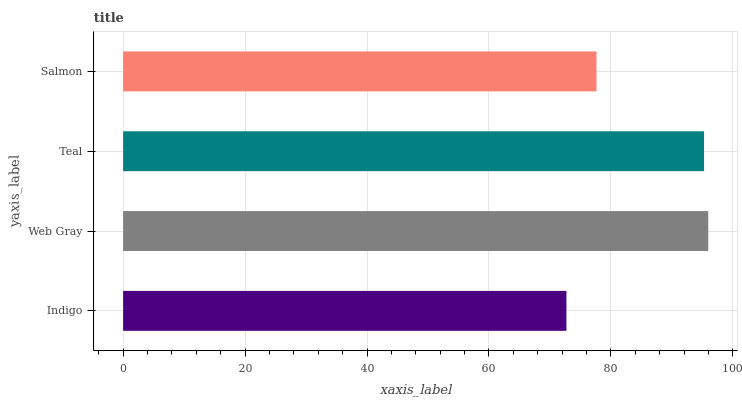Is Indigo the minimum?
Answer yes or no. Yes. Is Web Gray the maximum?
Answer yes or no. Yes. Is Teal the minimum?
Answer yes or no. No. Is Teal the maximum?
Answer yes or no. No. Is Web Gray greater than Teal?
Answer yes or no. Yes. Is Teal less than Web Gray?
Answer yes or no. Yes. Is Teal greater than Web Gray?
Answer yes or no. No. Is Web Gray less than Teal?
Answer yes or no. No. Is Teal the high median?
Answer yes or no. Yes. Is Salmon the low median?
Answer yes or no. Yes. Is Indigo the high median?
Answer yes or no. No. Is Teal the low median?
Answer yes or no. No. 